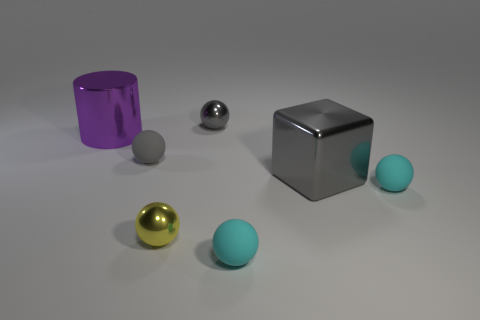What is the shape of the yellow object?
Your response must be concise. Sphere. How big is the gray metallic cube on the right side of the gray sphere that is to the right of the tiny yellow ball?
Offer a terse response. Large. Are there the same number of large gray shiny blocks on the left side of the purple thing and gray metal spheres to the left of the small yellow ball?
Ensure brevity in your answer.  Yes. There is a gray object that is on the right side of the small gray matte sphere and in front of the purple thing; what is its material?
Your response must be concise. Metal. There is a cylinder; is its size the same as the cyan ball right of the big gray block?
Your answer should be very brief. No. What number of other things are the same color as the cylinder?
Your answer should be very brief. 0. Are there more purple shiny things on the right side of the small yellow shiny thing than purple things?
Provide a succinct answer. No. There is a sphere that is to the right of the tiny rubber sphere that is in front of the cyan rubber object right of the large gray metal thing; what is its color?
Offer a very short reply. Cyan. Do the big purple cylinder and the cube have the same material?
Offer a terse response. Yes. Is there a brown rubber object that has the same size as the yellow shiny ball?
Ensure brevity in your answer.  No. 